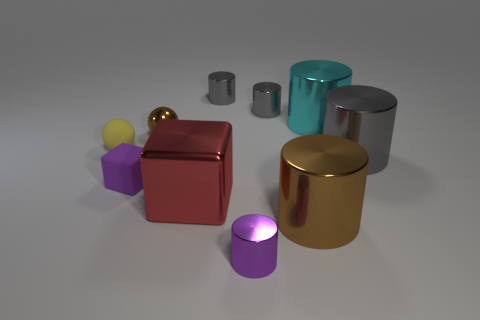Subtract all tiny purple cylinders. How many cylinders are left? 5 Subtract all yellow balls. How many balls are left? 1 Subtract all spheres. How many objects are left? 8 Subtract 2 cubes. How many cubes are left? 0 Subtract all blue cylinders. How many purple blocks are left? 1 Add 9 big red cubes. How many big red cubes exist? 10 Subtract 0 red cylinders. How many objects are left? 10 Subtract all yellow spheres. Subtract all gray cubes. How many spheres are left? 1 Subtract all brown matte spheres. Subtract all small yellow spheres. How many objects are left? 9 Add 6 red cubes. How many red cubes are left? 7 